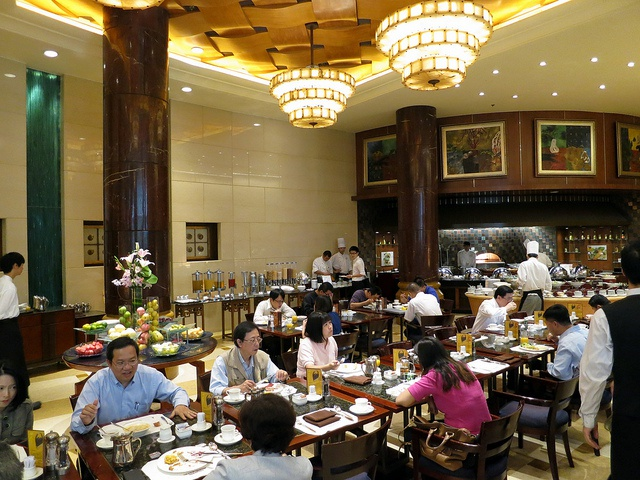Describe the objects in this image and their specific colors. I can see people in olive, black, darkgray, lightgray, and gray tones, dining table in olive, white, black, maroon, and gray tones, people in olive, gray, and darkgray tones, cup in olive, lightgray, darkgray, gray, and black tones, and people in olive, black, maroon, and purple tones in this image. 